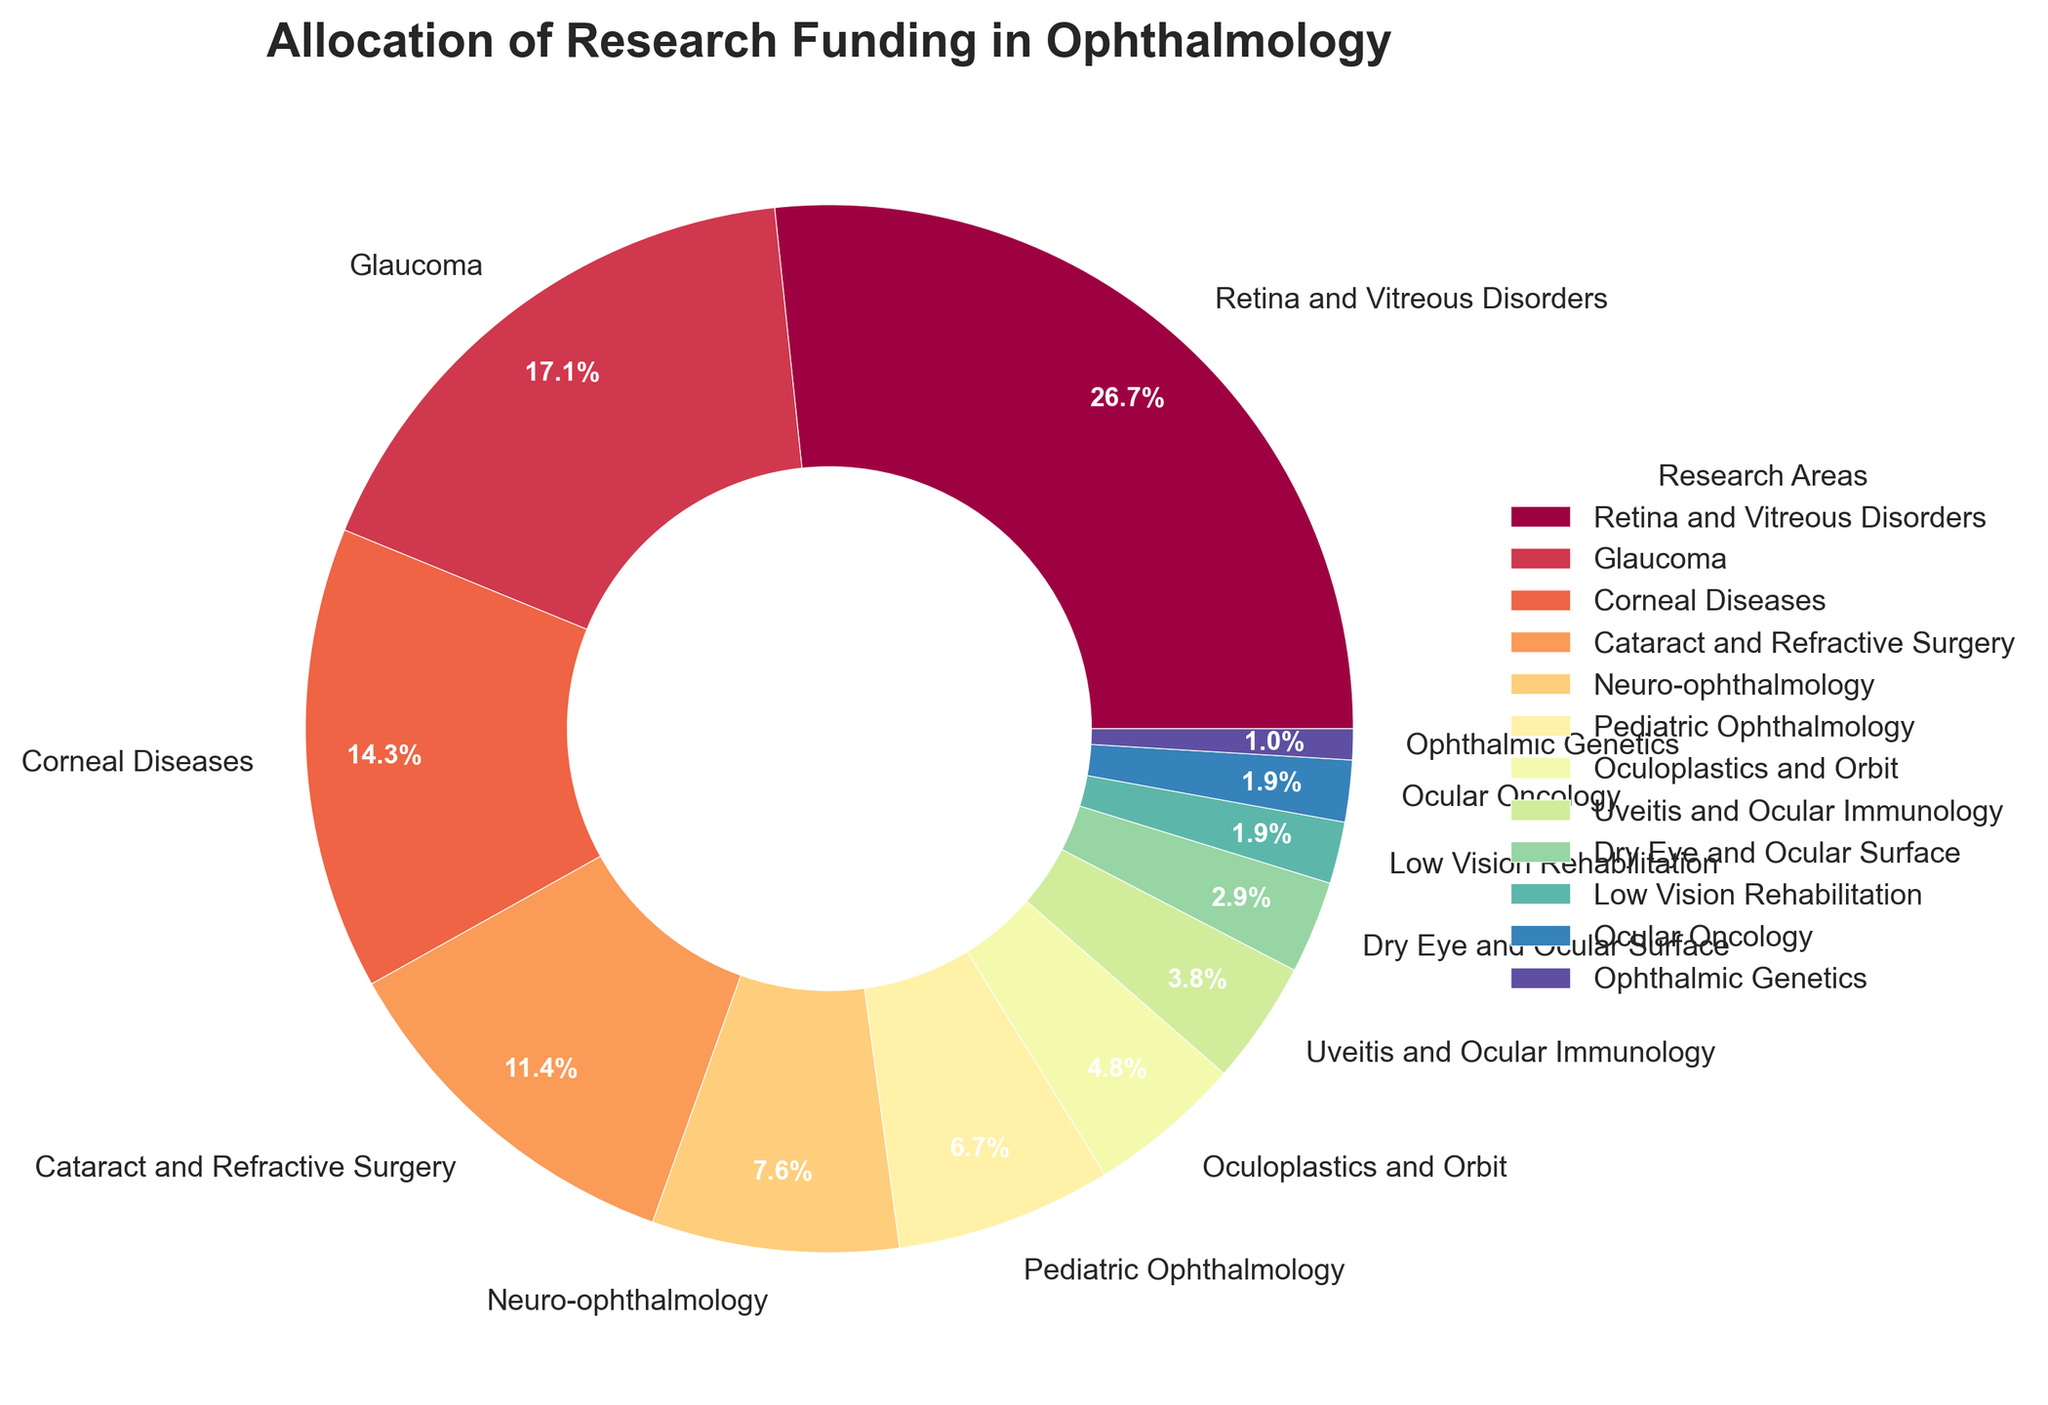What percentage of the total research funding is allocated to Retina and Vitreous Disorders and Corneal Diseases combined? To find the combined percentage, add the funding percentages for Retina and Vitreous Disorders (28%) and Corneal Diseases (15%). The combined allocation is 28% + 15% = 43%.
Answer: 43% Which research area receives the least amount of funding? The pie chart shows that Ophthalmic Genetics has the smallest slice, with a funding percentage of 1%.
Answer: Ophthalmic Genetics How much more funding does Glaucoma receive compared to Pediatric Ophthalmology? Glaucoma has 18% of the funding, and Pediatric Ophthalmology has 7%. To find the difference, subtract 7% from 18%. Hence, 18% - 7% = 11%.
Answer: 11% Which three research areas receive the highest amount of funding? By looking at the sizes of the slices in the pie chart, the three areas with the highest funding are Retina and Vitreous Disorders (28%), Glaucoma (18%), and Corneal Diseases (15%).
Answer: Retina and Vitreous Disorders, Glaucoma, Corneal Diseases What is the difference in combined funding between the three highest-funded research areas and the three lowest-funded research areas? The three highest-funded areas are Retina and Vitreous Disorders (28%), Glaucoma (18%), and Corneal Diseases (15%), summing to 28% + 18% + 15% = 61%. The three lowest-funded areas are Ophthalmic Genetics (1%), Low Vision Rehabilitation (2%), and Ocular Oncology (2%), summing to 1% + 2% + 2% = 5%. The difference is 61% - 5% = 56%.
Answer: 56% Which area receives the closest funding to that of Cataract and Refractive Surgery? Cataract and Refractive Surgery receives 12% funding. The area closest to this percentage is Neuro-ophthalmology with 8%, but no other area is exactly at 12%.
Answer: Neuro-ophthalmology What percentage of the total research funding is allocated to Dry Eye and Ocular Surface, and Low Vision Rehabilitation? The funding percentages for Dry Eye and Ocular Surface is 3% and Low Vision Rehabilitation is 2%. So, their combined total is 3% + 2% = 5%.
Answer: 5% Does Neuro-ophthalmology receive more or less funding than Pediatric Ophthalmology? The pie chart indicates that Neuro-ophthalmology receives 8% of the funding, while Pediatric Ophthalmology receives 7%. Thus, Neuro-ophthalmology receives 1% more.
Answer: More What is the average funding percentage for the areas that receive more than 10% of the funding? The areas receiving more than 10% funding are Retina and Vitreous Disorders (28%), Glaucoma (18%), and Corneal Diseases (15%), and Cataract and Refractive Surgery (12%). Calculate the average: (28% + 18% + 15% + 12%) / 4 = 73% / 4 = 18.25%.
Answer: 18.25% How many more areas receive funding below 10% compared to those above 10%? There are 8 areas that receive less than 10% funding: Neuro-ophthalmology, Pediatric Ophthalmology, Oculoplastics and Orbit, Uveitis and Ocular Immunology, Dry Eye and Ocular Surface, Low Vision Rehabilitation, Ocular Oncology, and Ophthalmic Genetics. The four areas receiving above 10% funding are Retina and Vitreous Disorders, Glaucoma, Corneal Diseases, and Cataract and Refractive Surgery. The difference is 8 - 4 = 4.
Answer: 4 